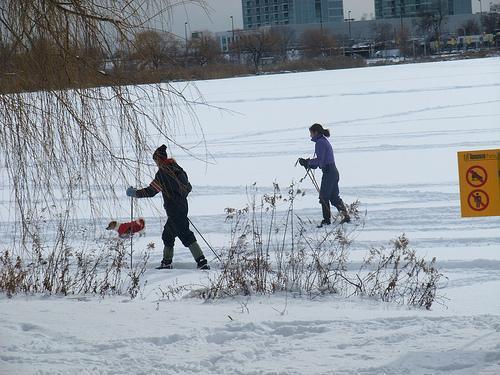How many kids?
Give a very brief answer. 2. 